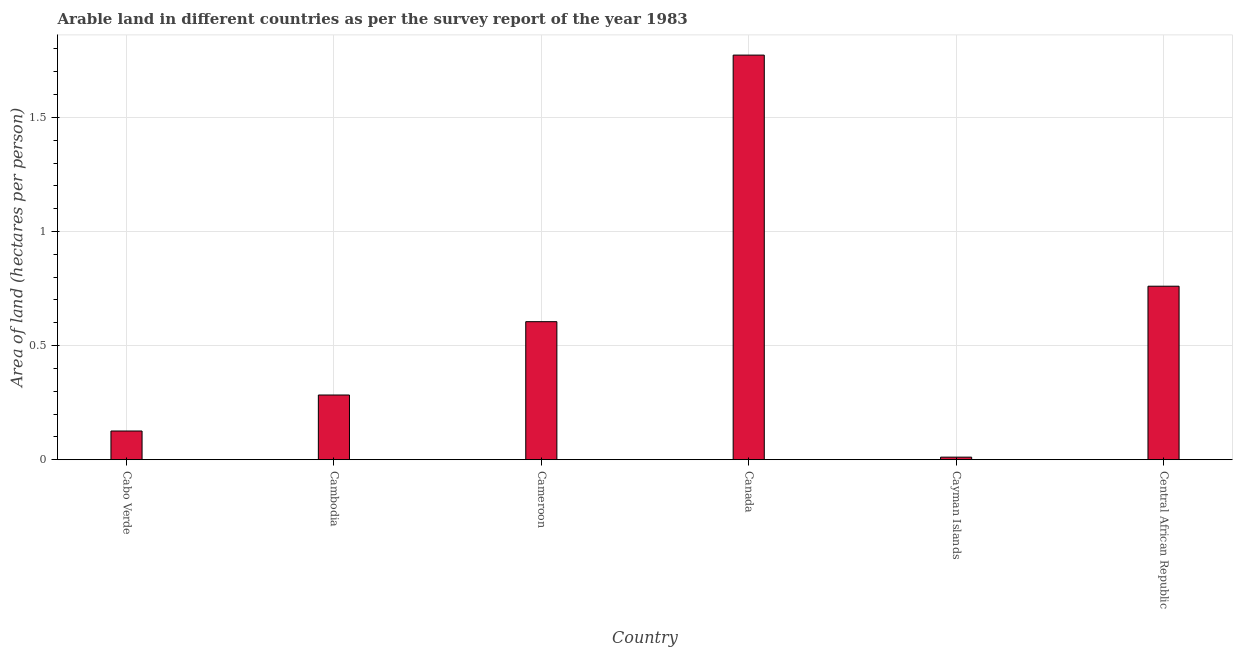Does the graph contain any zero values?
Make the answer very short. No. What is the title of the graph?
Your answer should be compact. Arable land in different countries as per the survey report of the year 1983. What is the label or title of the Y-axis?
Provide a succinct answer. Area of land (hectares per person). What is the area of arable land in Central African Republic?
Ensure brevity in your answer.  0.76. Across all countries, what is the maximum area of arable land?
Your response must be concise. 1.77. Across all countries, what is the minimum area of arable land?
Provide a short and direct response. 0.01. In which country was the area of arable land minimum?
Provide a succinct answer. Cayman Islands. What is the sum of the area of arable land?
Your response must be concise. 3.56. What is the difference between the area of arable land in Cameroon and Cayman Islands?
Your response must be concise. 0.59. What is the average area of arable land per country?
Ensure brevity in your answer.  0.59. What is the median area of arable land?
Your response must be concise. 0.44. In how many countries, is the area of arable land greater than 1 hectares per person?
Offer a terse response. 1. What is the ratio of the area of arable land in Cameroon to that in Canada?
Provide a short and direct response. 0.34. Is the difference between the area of arable land in Cabo Verde and Canada greater than the difference between any two countries?
Your answer should be very brief. No. Is the sum of the area of arable land in Cambodia and Cameroon greater than the maximum area of arable land across all countries?
Provide a succinct answer. No. What is the difference between the highest and the lowest area of arable land?
Ensure brevity in your answer.  1.76. In how many countries, is the area of arable land greater than the average area of arable land taken over all countries?
Offer a terse response. 3. Are all the bars in the graph horizontal?
Provide a short and direct response. No. What is the Area of land (hectares per person) in Cabo Verde?
Make the answer very short. 0.13. What is the Area of land (hectares per person) in Cambodia?
Offer a very short reply. 0.28. What is the Area of land (hectares per person) of Cameroon?
Offer a terse response. 0.6. What is the Area of land (hectares per person) in Canada?
Ensure brevity in your answer.  1.77. What is the Area of land (hectares per person) of Cayman Islands?
Provide a succinct answer. 0.01. What is the Area of land (hectares per person) of Central African Republic?
Make the answer very short. 0.76. What is the difference between the Area of land (hectares per person) in Cabo Verde and Cambodia?
Offer a very short reply. -0.16. What is the difference between the Area of land (hectares per person) in Cabo Verde and Cameroon?
Make the answer very short. -0.48. What is the difference between the Area of land (hectares per person) in Cabo Verde and Canada?
Your answer should be compact. -1.65. What is the difference between the Area of land (hectares per person) in Cabo Verde and Cayman Islands?
Make the answer very short. 0.11. What is the difference between the Area of land (hectares per person) in Cabo Verde and Central African Republic?
Your answer should be compact. -0.63. What is the difference between the Area of land (hectares per person) in Cambodia and Cameroon?
Offer a terse response. -0.32. What is the difference between the Area of land (hectares per person) in Cambodia and Canada?
Provide a succinct answer. -1.49. What is the difference between the Area of land (hectares per person) in Cambodia and Cayman Islands?
Your answer should be compact. 0.27. What is the difference between the Area of land (hectares per person) in Cambodia and Central African Republic?
Your response must be concise. -0.48. What is the difference between the Area of land (hectares per person) in Cameroon and Canada?
Your answer should be very brief. -1.17. What is the difference between the Area of land (hectares per person) in Cameroon and Cayman Islands?
Your response must be concise. 0.59. What is the difference between the Area of land (hectares per person) in Cameroon and Central African Republic?
Your answer should be compact. -0.16. What is the difference between the Area of land (hectares per person) in Canada and Cayman Islands?
Your answer should be very brief. 1.76. What is the difference between the Area of land (hectares per person) in Canada and Central African Republic?
Give a very brief answer. 1.01. What is the difference between the Area of land (hectares per person) in Cayman Islands and Central African Republic?
Keep it short and to the point. -0.75. What is the ratio of the Area of land (hectares per person) in Cabo Verde to that in Cambodia?
Your answer should be compact. 0.44. What is the ratio of the Area of land (hectares per person) in Cabo Verde to that in Cameroon?
Make the answer very short. 0.21. What is the ratio of the Area of land (hectares per person) in Cabo Verde to that in Canada?
Offer a very short reply. 0.07. What is the ratio of the Area of land (hectares per person) in Cabo Verde to that in Cayman Islands?
Offer a terse response. 11.26. What is the ratio of the Area of land (hectares per person) in Cabo Verde to that in Central African Republic?
Your answer should be very brief. 0.17. What is the ratio of the Area of land (hectares per person) in Cambodia to that in Cameroon?
Offer a terse response. 0.47. What is the ratio of the Area of land (hectares per person) in Cambodia to that in Canada?
Offer a terse response. 0.16. What is the ratio of the Area of land (hectares per person) in Cambodia to that in Cayman Islands?
Keep it short and to the point. 25.39. What is the ratio of the Area of land (hectares per person) in Cambodia to that in Central African Republic?
Provide a short and direct response. 0.37. What is the ratio of the Area of land (hectares per person) in Cameroon to that in Canada?
Give a very brief answer. 0.34. What is the ratio of the Area of land (hectares per person) in Cameroon to that in Cayman Islands?
Ensure brevity in your answer.  54.17. What is the ratio of the Area of land (hectares per person) in Cameroon to that in Central African Republic?
Offer a very short reply. 0.8. What is the ratio of the Area of land (hectares per person) in Canada to that in Cayman Islands?
Provide a succinct answer. 158.8. What is the ratio of the Area of land (hectares per person) in Canada to that in Central African Republic?
Your response must be concise. 2.33. What is the ratio of the Area of land (hectares per person) in Cayman Islands to that in Central African Republic?
Provide a short and direct response. 0.01. 